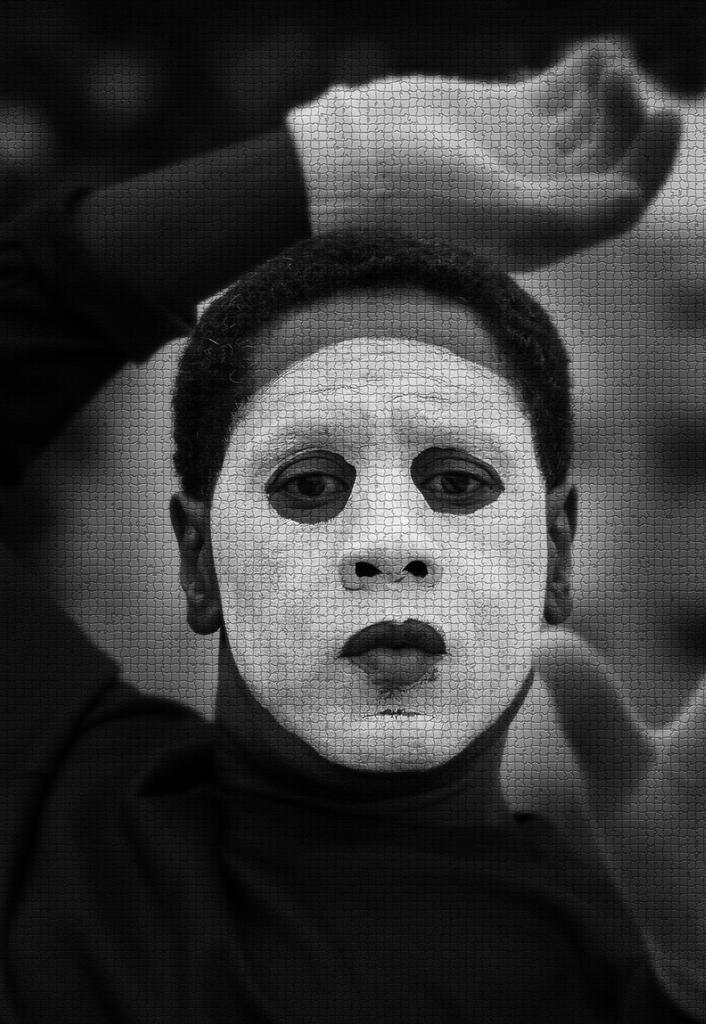What is the main subject of the picture? The main subject of the picture is a person. What protective gear is the person wearing? The person is wearing a face mask and hand gloves. What is the color scheme of the picture? The picture is black and white in color. What type of lace is used to decorate the person's clothing in the image? There is no lace visible in the image, as the person is wearing a face mask and hand gloves. What decision is the person making in the image? The image does not depict the person making any decisions; it only shows them wearing protective gear. 